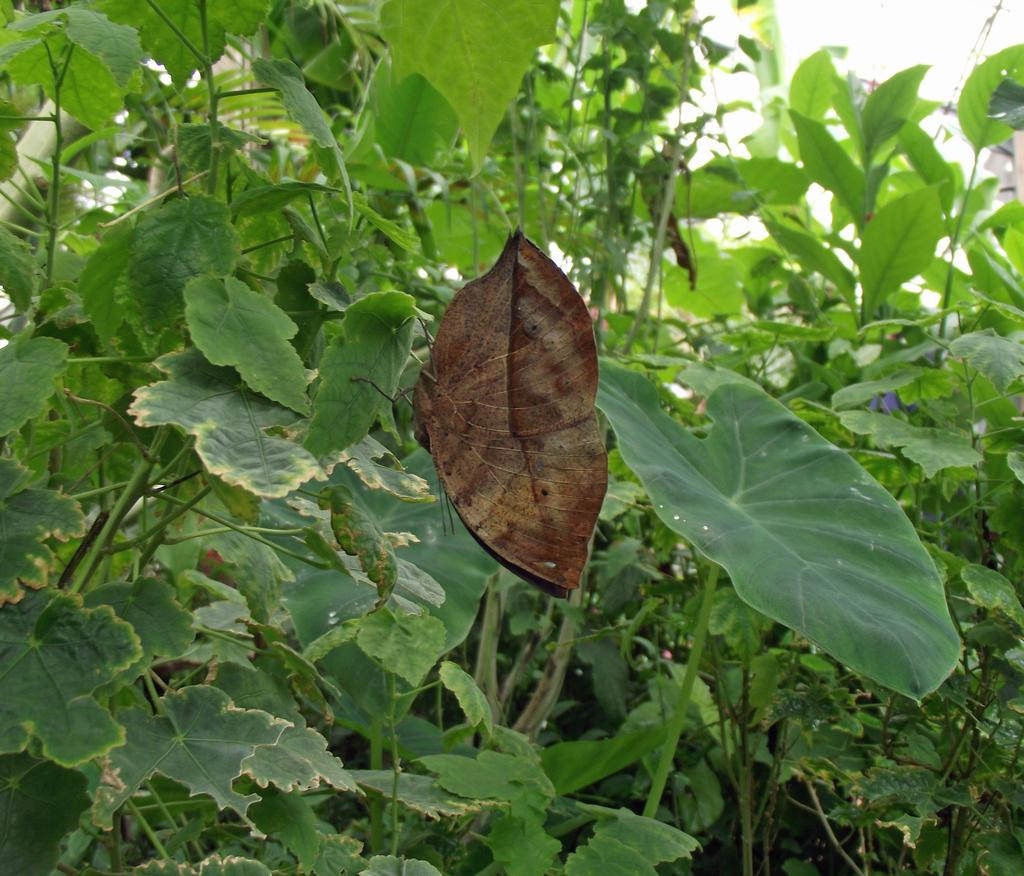What is the main subject of the image? There is a butterfly in the image. What can be seen in the background of the image? There are plants in the background of the image. How many hands are visible in the image? There are no hands visible in the image; it features a butterfly and plants in the background. What message of peace is being conveyed in the image? The image does not convey a message of peace, as it only shows a butterfly and plants in the background. 